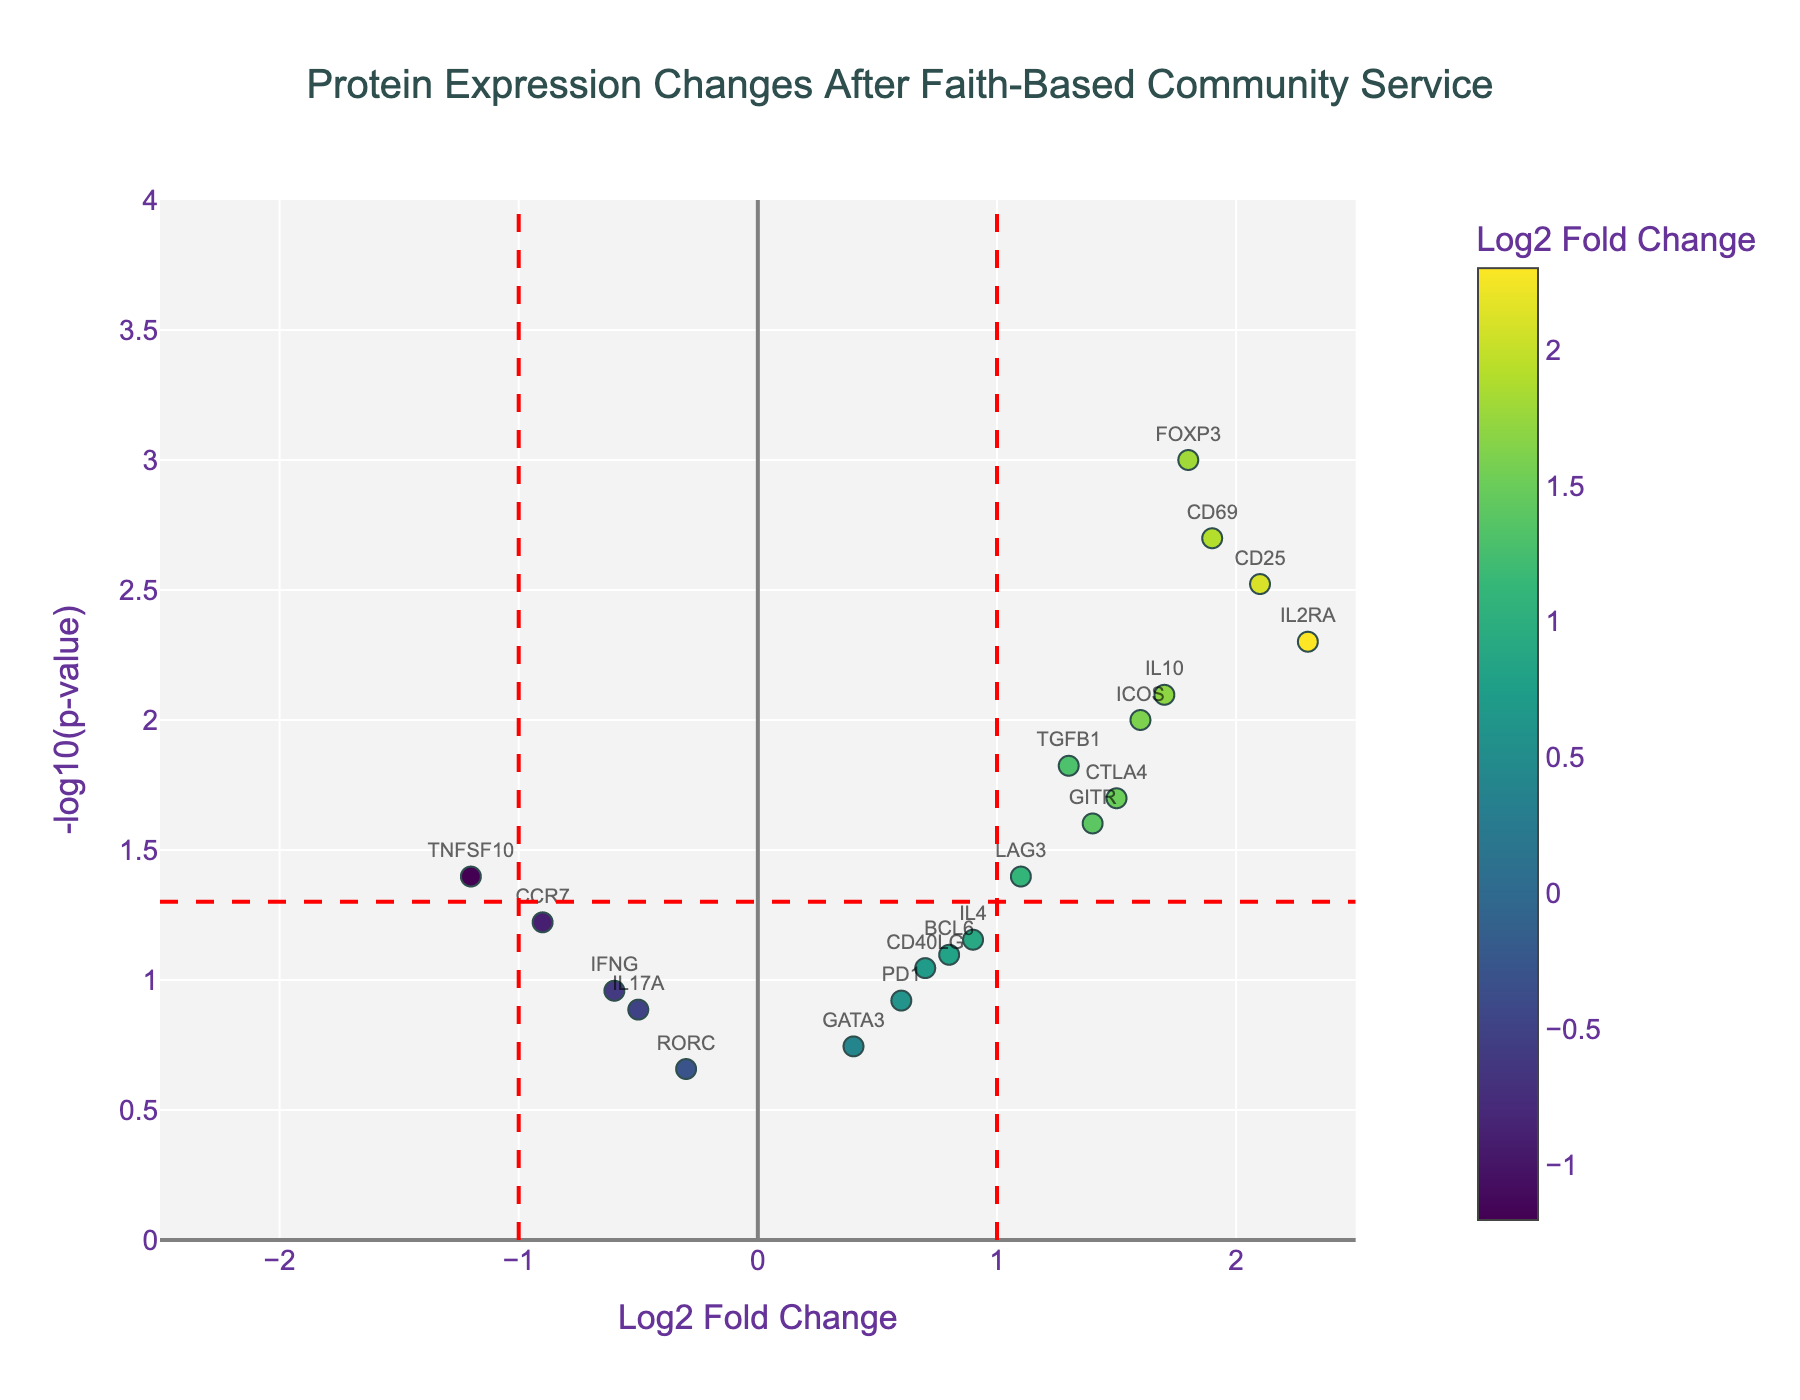What's the title of the figure? The title is typically found at the top of the figure. It often summarizes the main content or purpose of the figure. The title in this figure is "Protein Expression Changes After Faith-Based Community Service".
Answer: Protein Expression Changes After Faith-Based Community Service What is represented on the x-axis? The x-axis label is typically found below the horizontal axis. In this figure, it is labeled "Log2 Fold Change", which represents the logarithm (base 2) of the fold change in protein expression levels.
Answer: Log2 Fold Change How many proteins have a Log2 Fold Change greater than 1? In the figure, look for data points (proteins) where the x-axis value is greater than 1. Count these points to get the number. Proteins such as IL2RA, CD25, CD69, etc., fall in this category. By counting these data points, it's evident there are 6 proteins.
Answer: 6 Which protein has the highest p-value? The highest p-value corresponds to the smallest -log10(p-value) on the y-axis. Find the data point closest to y = 0. The protein at this point is RORC.
Answer: RORC Which proteins are significantly downregulated (Log2 Fold Change < -1 and p-value < 0.05)? Look for proteins where the x-axis value is less than -1 and the y-axis value is greater than -log10(0.05). We can see that only TNFSF10 meets these criteria.
Answer: TNFSF10 Compare the -log10(p-value) for IL2RA and FOXP3. Which is greater? Identify the data points for IL2RA and FOXP3. Compare their y-axis values (-log10(p-value)). IL2RA has a higher -log10(p-value) than FOXP3.
Answer: IL2RA What is the Log2 Fold Change of the protein with the second lowest p-value? The second lowest p-value corresponds to the second highest -log10(p-value). The highest -log10(p-value) protein is FOXP3, followed by CD25. The Log2 Fold Change for CD25 is 2.1.
Answer: 2.1 Are there any proteins with a Log2 Fold Change between -0.5 and 0.5? Look for proteins where the x-axis value falls within the range of -0.5 to 0.5. The proteins with Log2 Fold Changes between -0.5 and 0.5 are GATA3 and RORC.
Answer: GATA3, RORC What is the -log10(p-value) for a p-value of 0.05, and which line in the plot signifies this? -log10(p-value) can be calculated as -log10(0.05). This value is approximately 1.3. In the plot, this is represented by a horizontal dashed red line.
Answer: 1.3 Do any of the proteins have a Log2 Fold Change exactly at 0.5? Look at the x-axis and check if any data points are at the value 0.5. Upon reviewing, there are no proteins with a Log2 Fold Change exactly at 0.5 in the plot.
Answer: No 